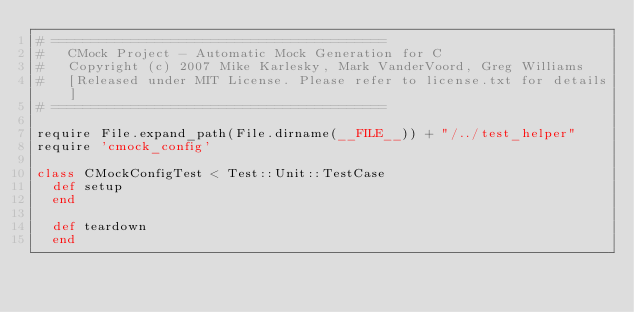<code> <loc_0><loc_0><loc_500><loc_500><_Ruby_># ==========================================
#   CMock Project - Automatic Mock Generation for C
#   Copyright (c) 2007 Mike Karlesky, Mark VanderVoord, Greg Williams
#   [Released under MIT License. Please refer to license.txt for details]
# ========================================== 

require File.expand_path(File.dirname(__FILE__)) + "/../test_helper"
require 'cmock_config'

class CMockConfigTest < Test::Unit::TestCase
  def setup
  end

  def teardown
  end
  </code> 